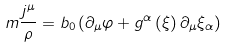<formula> <loc_0><loc_0><loc_500><loc_500>m \frac { j ^ { \mu } } { \rho } = b _ { 0 } \left ( \partial _ { \mu } \varphi + g ^ { \alpha } \left ( \xi \right ) \partial _ { \mu } \xi _ { \alpha } \right )</formula> 